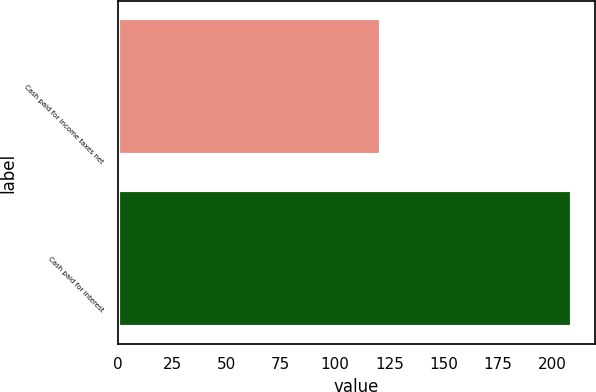<chart> <loc_0><loc_0><loc_500><loc_500><bar_chart><fcel>Cash paid for income taxes net<fcel>Cash paid for interest<nl><fcel>121<fcel>209<nl></chart> 